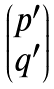Convert formula to latex. <formula><loc_0><loc_0><loc_500><loc_500>\begin{pmatrix} p ^ { \prime } \\ q ^ { \prime } \end{pmatrix}</formula> 